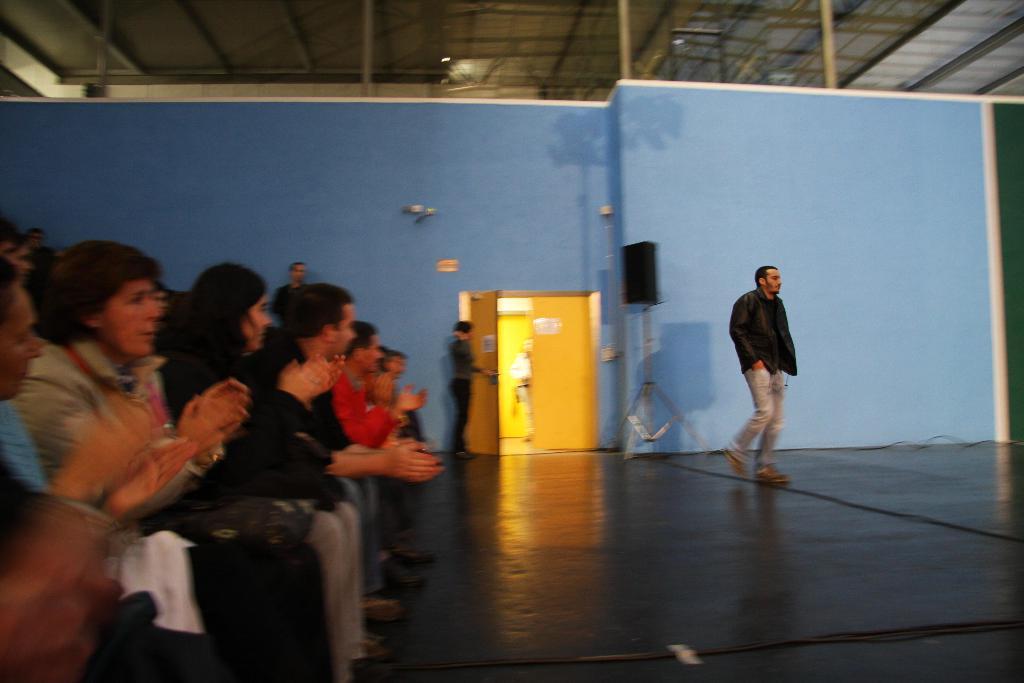How would you summarize this image in a sentence or two? In this image I can see a person wearing black jacket, pant and footwear is walking on the ground and to the left side of the image I can see few persons sitting on chairs and clapping. In the background I can see few persons standing, the blue colored wall, the yellow colored door and the roof of the building. 